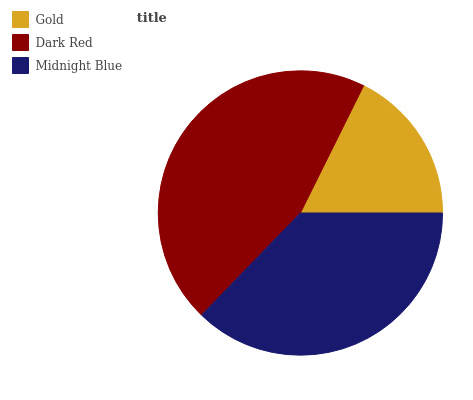Is Gold the minimum?
Answer yes or no. Yes. Is Dark Red the maximum?
Answer yes or no. Yes. Is Midnight Blue the minimum?
Answer yes or no. No. Is Midnight Blue the maximum?
Answer yes or no. No. Is Dark Red greater than Midnight Blue?
Answer yes or no. Yes. Is Midnight Blue less than Dark Red?
Answer yes or no. Yes. Is Midnight Blue greater than Dark Red?
Answer yes or no. No. Is Dark Red less than Midnight Blue?
Answer yes or no. No. Is Midnight Blue the high median?
Answer yes or no. Yes. Is Midnight Blue the low median?
Answer yes or no. Yes. Is Gold the high median?
Answer yes or no. No. Is Gold the low median?
Answer yes or no. No. 